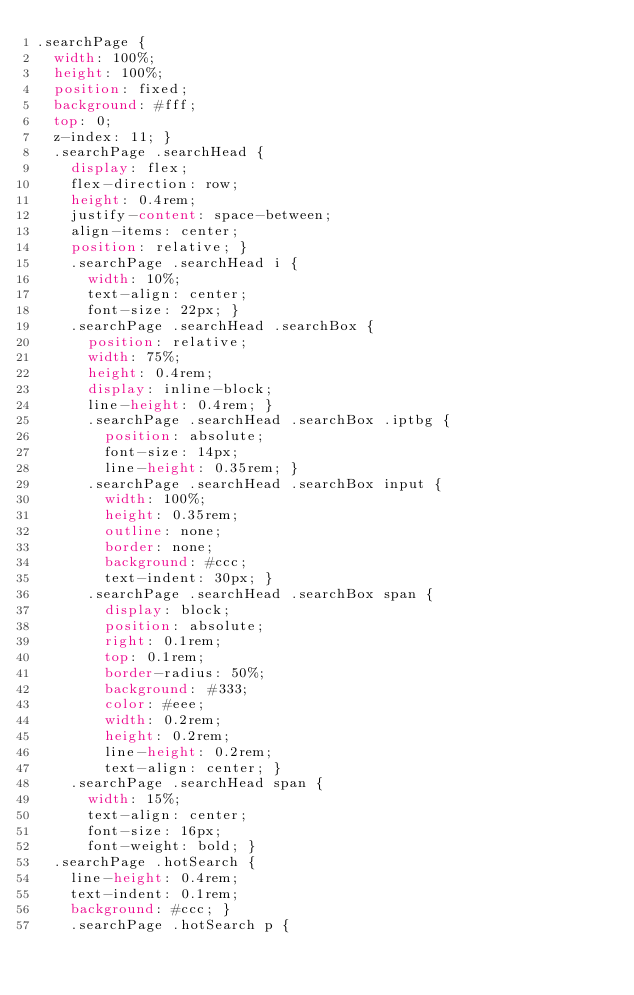<code> <loc_0><loc_0><loc_500><loc_500><_CSS_>.searchPage {
  width: 100%;
  height: 100%;
  position: fixed;
  background: #fff;
  top: 0;
  z-index: 11; }
  .searchPage .searchHead {
    display: flex;
    flex-direction: row;
    height: 0.4rem;
    justify-content: space-between;
    align-items: center;
    position: relative; }
    .searchPage .searchHead i {
      width: 10%;
      text-align: center;
      font-size: 22px; }
    .searchPage .searchHead .searchBox {
      position: relative;
      width: 75%;
      height: 0.4rem;
      display: inline-block;
      line-height: 0.4rem; }
      .searchPage .searchHead .searchBox .iptbg {
        position: absolute;
        font-size: 14px;
        line-height: 0.35rem; }
      .searchPage .searchHead .searchBox input {
        width: 100%;
        height: 0.35rem;
        outline: none;
        border: none;
        background: #ccc;
        text-indent: 30px; }
      .searchPage .searchHead .searchBox span {
        display: block;
        position: absolute;
        right: 0.1rem;
        top: 0.1rem;
        border-radius: 50%;
        background: #333;
        color: #eee;
        width: 0.2rem;
        height: 0.2rem;
        line-height: 0.2rem;
        text-align: center; }
    .searchPage .searchHead span {
      width: 15%;
      text-align: center;
      font-size: 16px;
      font-weight: bold; }
  .searchPage .hotSearch {
    line-height: 0.4rem;
    text-indent: 0.1rem;
    background: #ccc; }
    .searchPage .hotSearch p {</code> 